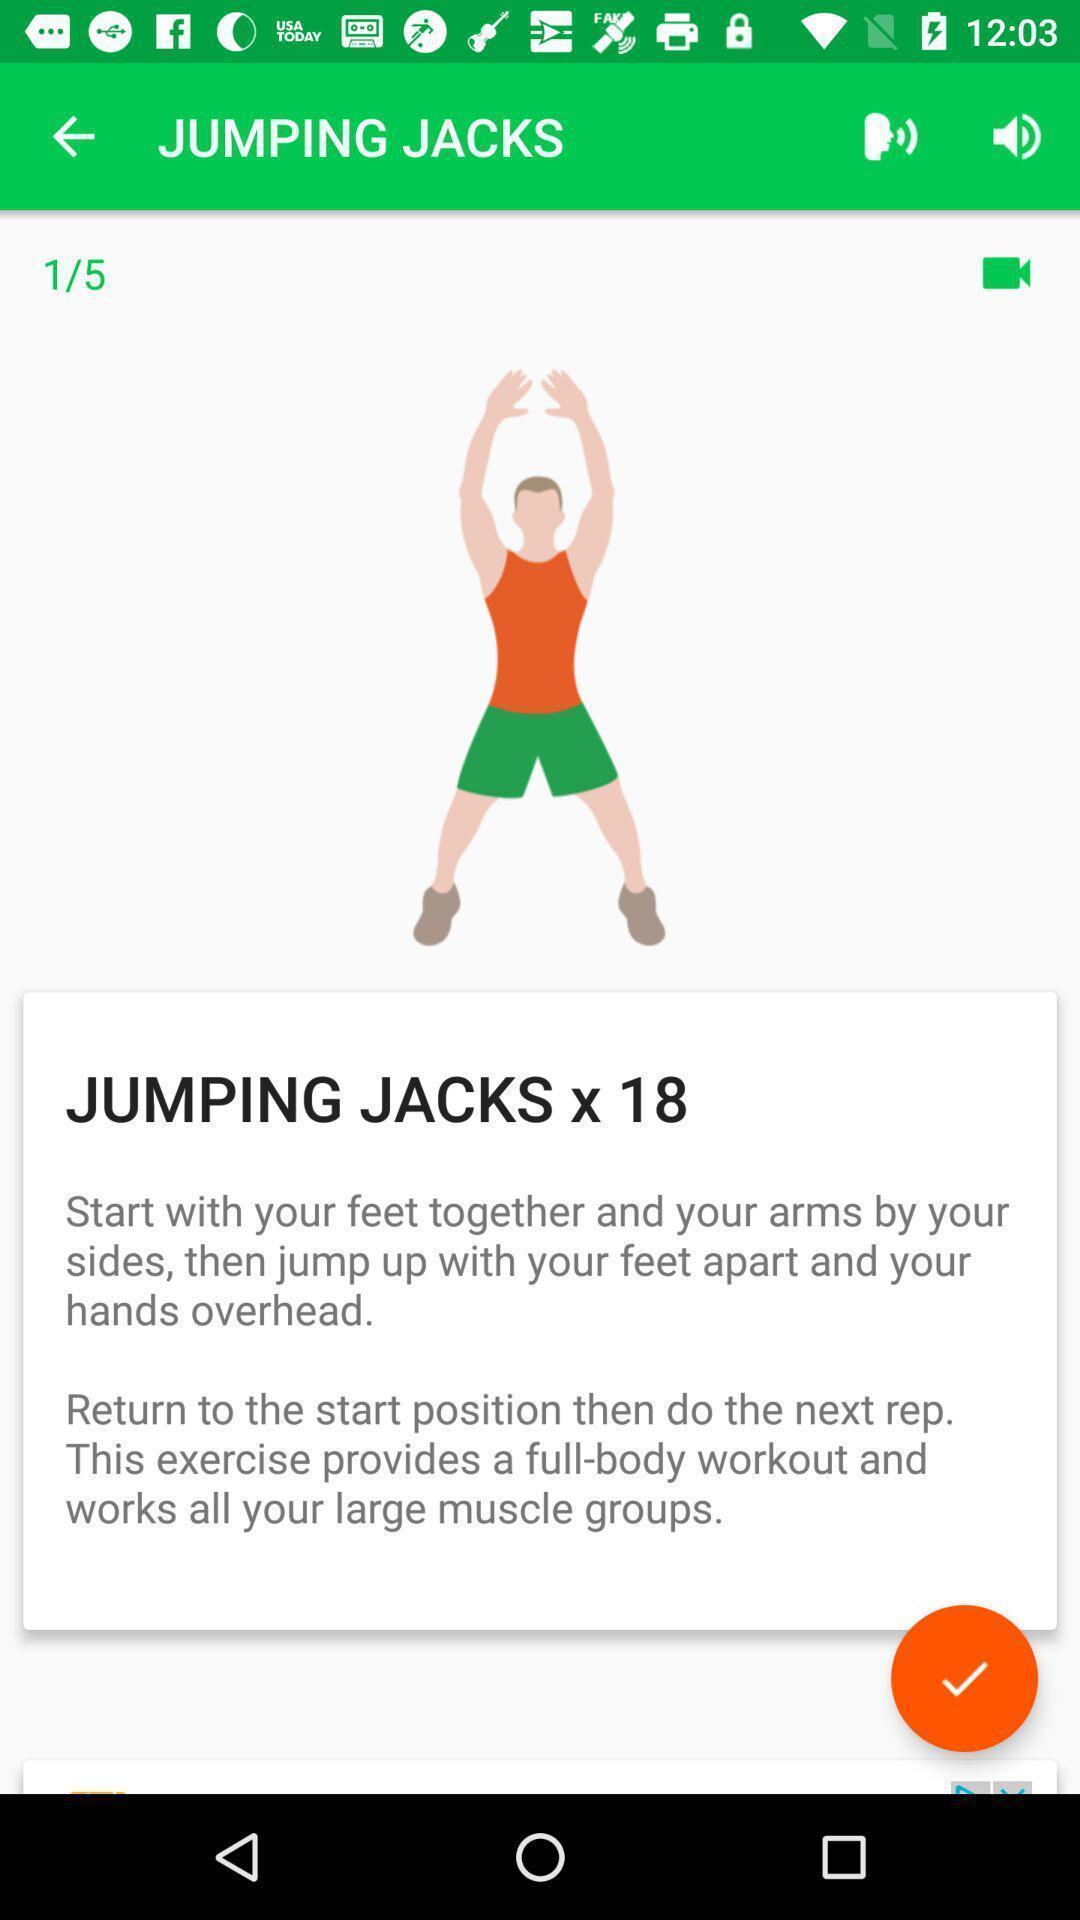Describe the visual elements of this screenshot. Screen page of a fitness application. 